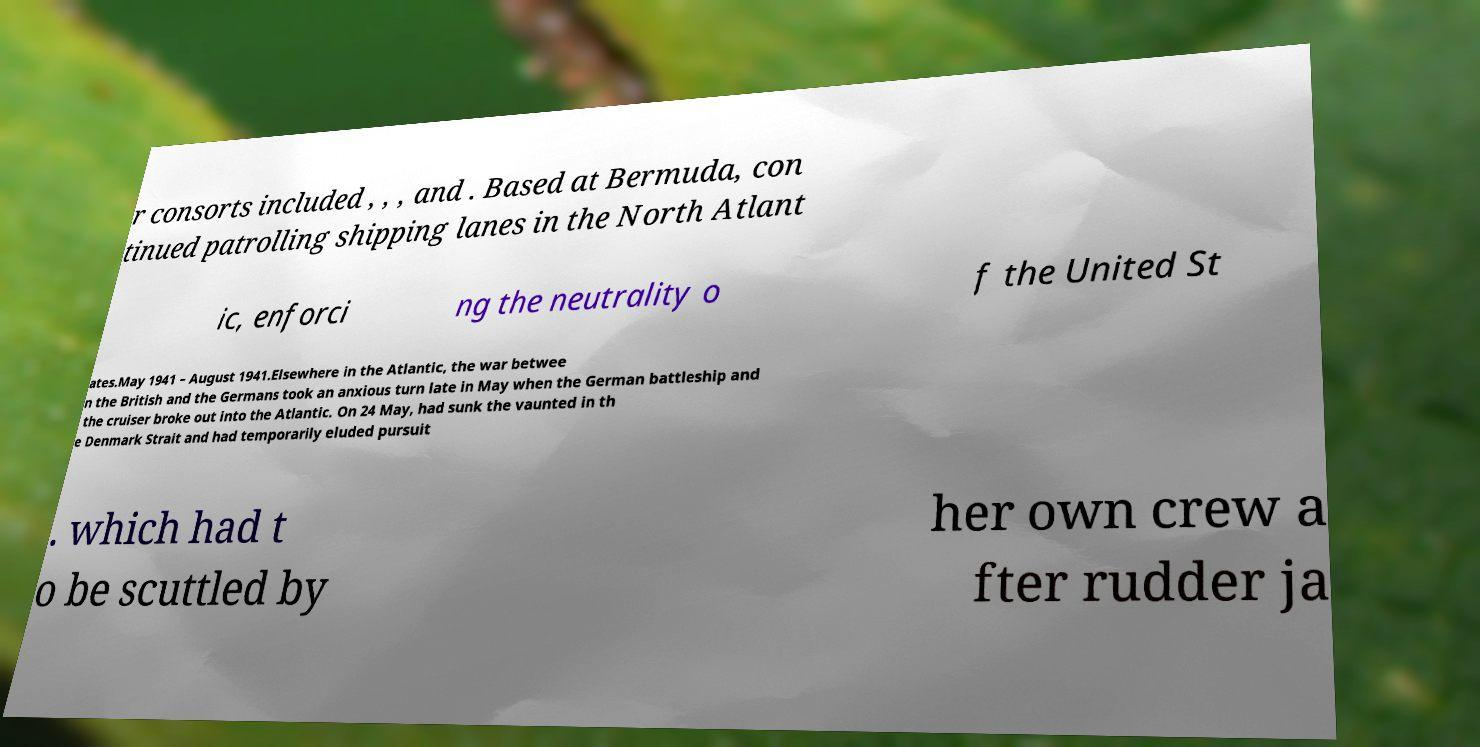Please identify and transcribe the text found in this image. r consorts included , , , and . Based at Bermuda, con tinued patrolling shipping lanes in the North Atlant ic, enforci ng the neutrality o f the United St ates.May 1941 – August 1941.Elsewhere in the Atlantic, the war betwee n the British and the Germans took an anxious turn late in May when the German battleship and the cruiser broke out into the Atlantic. On 24 May, had sunk the vaunted in th e Denmark Strait and had temporarily eluded pursuit . which had t o be scuttled by her own crew a fter rudder ja 